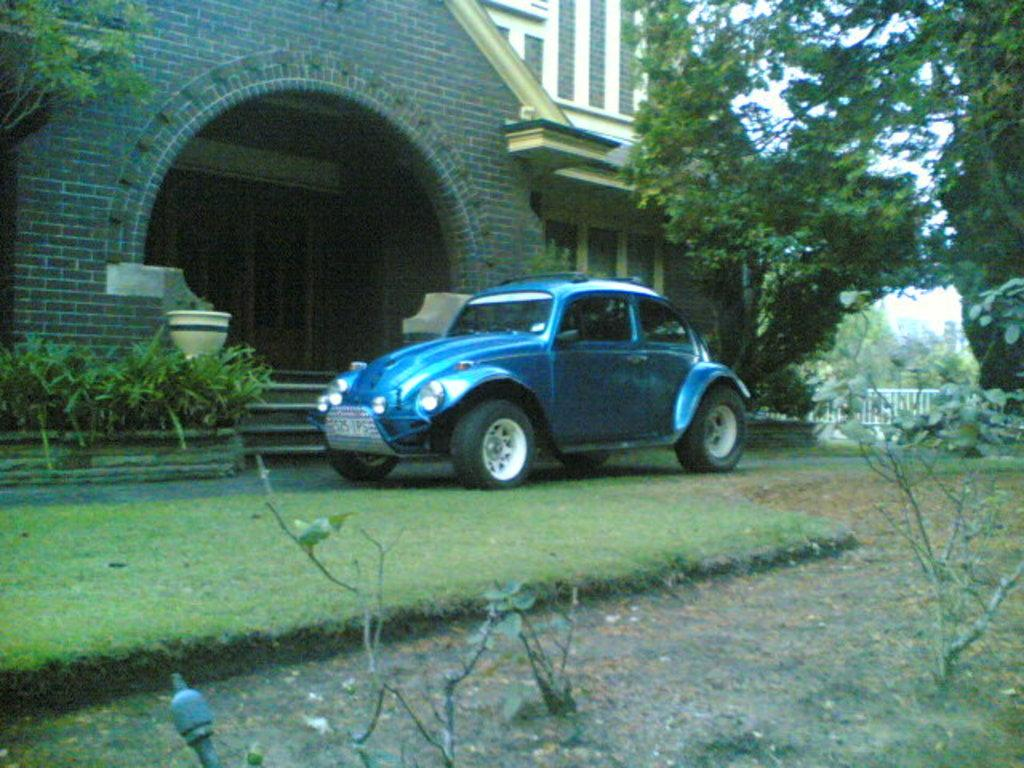What color is present on the land in the image? There is a blue color on the land in the image. What type of area can be seen in the image? There is a garden in the image. What type of vegetation is present in the image? There are plants and trees in the image. What can be seen in the background of the image? There is a building in the background of the image. What type of game is being played in the garden in the image? There is no game being played in the garden in the image; it simply shows a garden with plants, trees, and a blue color on the land. 